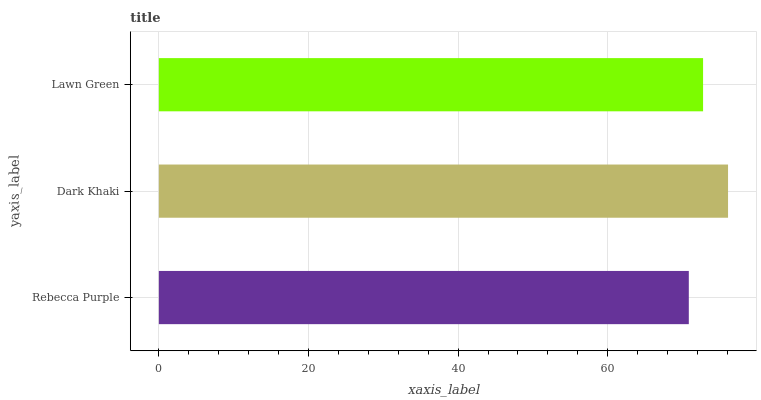Is Rebecca Purple the minimum?
Answer yes or no. Yes. Is Dark Khaki the maximum?
Answer yes or no. Yes. Is Lawn Green the minimum?
Answer yes or no. No. Is Lawn Green the maximum?
Answer yes or no. No. Is Dark Khaki greater than Lawn Green?
Answer yes or no. Yes. Is Lawn Green less than Dark Khaki?
Answer yes or no. Yes. Is Lawn Green greater than Dark Khaki?
Answer yes or no. No. Is Dark Khaki less than Lawn Green?
Answer yes or no. No. Is Lawn Green the high median?
Answer yes or no. Yes. Is Lawn Green the low median?
Answer yes or no. Yes. Is Dark Khaki the high median?
Answer yes or no. No. Is Dark Khaki the low median?
Answer yes or no. No. 